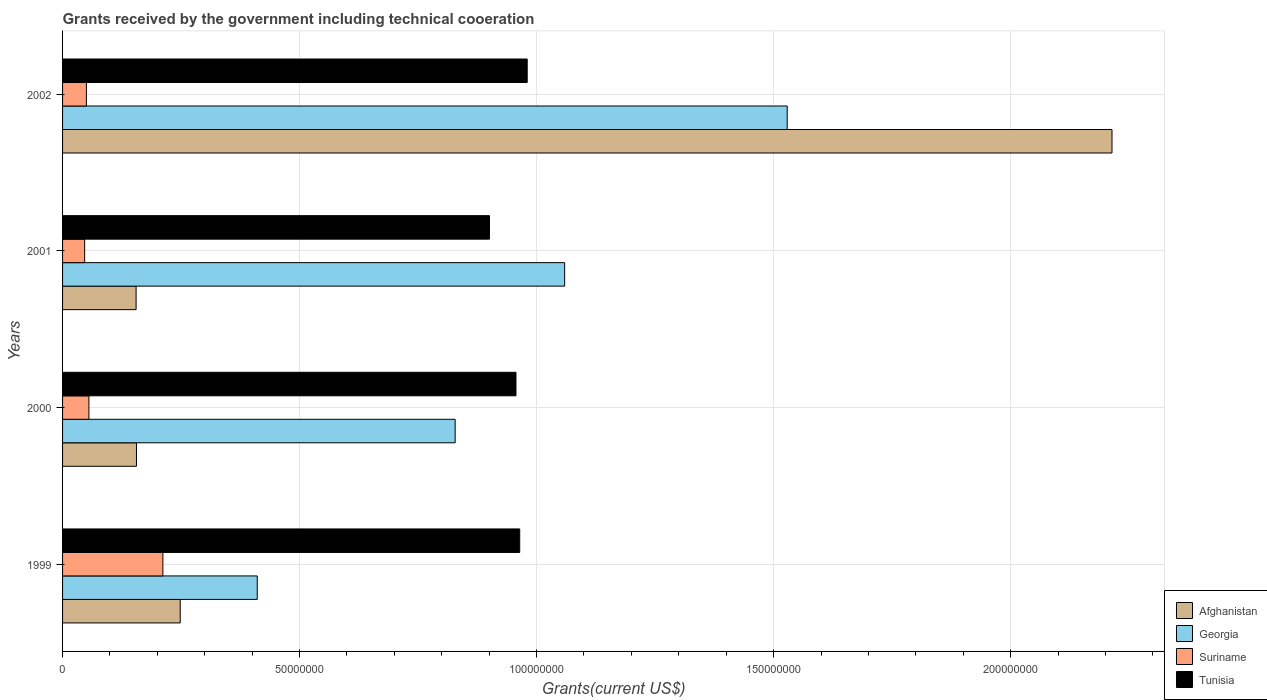Are the number of bars per tick equal to the number of legend labels?
Make the answer very short. Yes. Are the number of bars on each tick of the Y-axis equal?
Your answer should be compact. Yes. How many bars are there on the 3rd tick from the top?
Offer a terse response. 4. What is the label of the 1st group of bars from the top?
Ensure brevity in your answer.  2002. What is the total grants received by the government in Georgia in 2001?
Your response must be concise. 1.06e+08. Across all years, what is the maximum total grants received by the government in Tunisia?
Provide a succinct answer. 9.80e+07. Across all years, what is the minimum total grants received by the government in Afghanistan?
Offer a very short reply. 1.55e+07. What is the total total grants received by the government in Suriname in the graph?
Your answer should be very brief. 3.64e+07. What is the difference between the total grants received by the government in Suriname in 2000 and that in 2002?
Provide a short and direct response. 5.30e+05. What is the difference between the total grants received by the government in Georgia in 2000 and the total grants received by the government in Afghanistan in 2002?
Offer a very short reply. -1.39e+08. What is the average total grants received by the government in Georgia per year?
Your response must be concise. 9.57e+07. In the year 2001, what is the difference between the total grants received by the government in Georgia and total grants received by the government in Tunisia?
Make the answer very short. 1.59e+07. What is the ratio of the total grants received by the government in Suriname in 2000 to that in 2002?
Offer a very short reply. 1.11. Is the difference between the total grants received by the government in Georgia in 1999 and 2000 greater than the difference between the total grants received by the government in Tunisia in 1999 and 2000?
Offer a very short reply. No. What is the difference between the highest and the second highest total grants received by the government in Suriname?
Your answer should be compact. 1.56e+07. What is the difference between the highest and the lowest total grants received by the government in Suriname?
Offer a very short reply. 1.65e+07. Is the sum of the total grants received by the government in Afghanistan in 2000 and 2002 greater than the maximum total grants received by the government in Suriname across all years?
Your answer should be very brief. Yes. Is it the case that in every year, the sum of the total grants received by the government in Tunisia and total grants received by the government in Georgia is greater than the sum of total grants received by the government in Suriname and total grants received by the government in Afghanistan?
Keep it short and to the point. No. What does the 1st bar from the top in 2000 represents?
Make the answer very short. Tunisia. What does the 2nd bar from the bottom in 2001 represents?
Provide a short and direct response. Georgia. How many bars are there?
Your answer should be very brief. 16. What is the difference between two consecutive major ticks on the X-axis?
Keep it short and to the point. 5.00e+07. Are the values on the major ticks of X-axis written in scientific E-notation?
Offer a terse response. No. How many legend labels are there?
Your answer should be compact. 4. What is the title of the graph?
Keep it short and to the point. Grants received by the government including technical cooeration. Does "Sao Tome and Principe" appear as one of the legend labels in the graph?
Your response must be concise. No. What is the label or title of the X-axis?
Provide a succinct answer. Grants(current US$). What is the Grants(current US$) of Afghanistan in 1999?
Provide a short and direct response. 2.48e+07. What is the Grants(current US$) in Georgia in 1999?
Keep it short and to the point. 4.11e+07. What is the Grants(current US$) in Suriname in 1999?
Your answer should be very brief. 2.12e+07. What is the Grants(current US$) of Tunisia in 1999?
Offer a very short reply. 9.64e+07. What is the Grants(current US$) of Afghanistan in 2000?
Your response must be concise. 1.56e+07. What is the Grants(current US$) of Georgia in 2000?
Your answer should be very brief. 8.28e+07. What is the Grants(current US$) of Suriname in 2000?
Make the answer very short. 5.56e+06. What is the Grants(current US$) in Tunisia in 2000?
Offer a terse response. 9.56e+07. What is the Grants(current US$) of Afghanistan in 2001?
Provide a short and direct response. 1.55e+07. What is the Grants(current US$) of Georgia in 2001?
Your response must be concise. 1.06e+08. What is the Grants(current US$) in Suriname in 2001?
Your answer should be very brief. 4.66e+06. What is the Grants(current US$) in Tunisia in 2001?
Your answer should be compact. 9.01e+07. What is the Grants(current US$) in Afghanistan in 2002?
Make the answer very short. 2.21e+08. What is the Grants(current US$) in Georgia in 2002?
Your answer should be compact. 1.53e+08. What is the Grants(current US$) in Suriname in 2002?
Provide a succinct answer. 5.03e+06. What is the Grants(current US$) of Tunisia in 2002?
Offer a terse response. 9.80e+07. Across all years, what is the maximum Grants(current US$) in Afghanistan?
Your answer should be very brief. 2.21e+08. Across all years, what is the maximum Grants(current US$) of Georgia?
Offer a very short reply. 1.53e+08. Across all years, what is the maximum Grants(current US$) in Suriname?
Your answer should be very brief. 2.12e+07. Across all years, what is the maximum Grants(current US$) in Tunisia?
Your answer should be very brief. 9.80e+07. Across all years, what is the minimum Grants(current US$) of Afghanistan?
Offer a very short reply. 1.55e+07. Across all years, what is the minimum Grants(current US$) in Georgia?
Ensure brevity in your answer.  4.11e+07. Across all years, what is the minimum Grants(current US$) of Suriname?
Offer a terse response. 4.66e+06. Across all years, what is the minimum Grants(current US$) in Tunisia?
Provide a short and direct response. 9.01e+07. What is the total Grants(current US$) of Afghanistan in the graph?
Offer a terse response. 2.77e+08. What is the total Grants(current US$) of Georgia in the graph?
Offer a very short reply. 3.83e+08. What is the total Grants(current US$) of Suriname in the graph?
Offer a very short reply. 3.64e+07. What is the total Grants(current US$) in Tunisia in the graph?
Provide a succinct answer. 3.80e+08. What is the difference between the Grants(current US$) of Afghanistan in 1999 and that in 2000?
Your response must be concise. 9.23e+06. What is the difference between the Grants(current US$) of Georgia in 1999 and that in 2000?
Make the answer very short. -4.18e+07. What is the difference between the Grants(current US$) of Suriname in 1999 and that in 2000?
Provide a short and direct response. 1.56e+07. What is the difference between the Grants(current US$) in Tunisia in 1999 and that in 2000?
Your answer should be very brief. 7.90e+05. What is the difference between the Grants(current US$) of Afghanistan in 1999 and that in 2001?
Provide a succinct answer. 9.31e+06. What is the difference between the Grants(current US$) in Georgia in 1999 and that in 2001?
Give a very brief answer. -6.48e+07. What is the difference between the Grants(current US$) in Suriname in 1999 and that in 2001?
Your answer should be very brief. 1.65e+07. What is the difference between the Grants(current US$) of Tunisia in 1999 and that in 2001?
Ensure brevity in your answer.  6.38e+06. What is the difference between the Grants(current US$) in Afghanistan in 1999 and that in 2002?
Ensure brevity in your answer.  -1.97e+08. What is the difference between the Grants(current US$) of Georgia in 1999 and that in 2002?
Your response must be concise. -1.12e+08. What is the difference between the Grants(current US$) in Suriname in 1999 and that in 2002?
Your response must be concise. 1.61e+07. What is the difference between the Grants(current US$) of Tunisia in 1999 and that in 2002?
Your response must be concise. -1.58e+06. What is the difference between the Grants(current US$) in Georgia in 2000 and that in 2001?
Offer a terse response. -2.31e+07. What is the difference between the Grants(current US$) in Tunisia in 2000 and that in 2001?
Offer a very short reply. 5.59e+06. What is the difference between the Grants(current US$) in Afghanistan in 2000 and that in 2002?
Provide a short and direct response. -2.06e+08. What is the difference between the Grants(current US$) in Georgia in 2000 and that in 2002?
Keep it short and to the point. -7.00e+07. What is the difference between the Grants(current US$) in Suriname in 2000 and that in 2002?
Provide a short and direct response. 5.30e+05. What is the difference between the Grants(current US$) in Tunisia in 2000 and that in 2002?
Keep it short and to the point. -2.37e+06. What is the difference between the Grants(current US$) in Afghanistan in 2001 and that in 2002?
Keep it short and to the point. -2.06e+08. What is the difference between the Grants(current US$) in Georgia in 2001 and that in 2002?
Your answer should be compact. -4.70e+07. What is the difference between the Grants(current US$) of Suriname in 2001 and that in 2002?
Ensure brevity in your answer.  -3.70e+05. What is the difference between the Grants(current US$) of Tunisia in 2001 and that in 2002?
Make the answer very short. -7.96e+06. What is the difference between the Grants(current US$) of Afghanistan in 1999 and the Grants(current US$) of Georgia in 2000?
Your response must be concise. -5.80e+07. What is the difference between the Grants(current US$) of Afghanistan in 1999 and the Grants(current US$) of Suriname in 2000?
Your answer should be compact. 1.93e+07. What is the difference between the Grants(current US$) of Afghanistan in 1999 and the Grants(current US$) of Tunisia in 2000?
Your response must be concise. -7.08e+07. What is the difference between the Grants(current US$) of Georgia in 1999 and the Grants(current US$) of Suriname in 2000?
Offer a very short reply. 3.55e+07. What is the difference between the Grants(current US$) in Georgia in 1999 and the Grants(current US$) in Tunisia in 2000?
Keep it short and to the point. -5.46e+07. What is the difference between the Grants(current US$) in Suriname in 1999 and the Grants(current US$) in Tunisia in 2000?
Your answer should be compact. -7.45e+07. What is the difference between the Grants(current US$) in Afghanistan in 1999 and the Grants(current US$) in Georgia in 2001?
Your answer should be compact. -8.11e+07. What is the difference between the Grants(current US$) in Afghanistan in 1999 and the Grants(current US$) in Suriname in 2001?
Offer a terse response. 2.02e+07. What is the difference between the Grants(current US$) of Afghanistan in 1999 and the Grants(current US$) of Tunisia in 2001?
Offer a terse response. -6.52e+07. What is the difference between the Grants(current US$) of Georgia in 1999 and the Grants(current US$) of Suriname in 2001?
Ensure brevity in your answer.  3.64e+07. What is the difference between the Grants(current US$) in Georgia in 1999 and the Grants(current US$) in Tunisia in 2001?
Your answer should be very brief. -4.90e+07. What is the difference between the Grants(current US$) of Suriname in 1999 and the Grants(current US$) of Tunisia in 2001?
Provide a succinct answer. -6.89e+07. What is the difference between the Grants(current US$) of Afghanistan in 1999 and the Grants(current US$) of Georgia in 2002?
Make the answer very short. -1.28e+08. What is the difference between the Grants(current US$) in Afghanistan in 1999 and the Grants(current US$) in Suriname in 2002?
Provide a short and direct response. 1.98e+07. What is the difference between the Grants(current US$) in Afghanistan in 1999 and the Grants(current US$) in Tunisia in 2002?
Offer a very short reply. -7.32e+07. What is the difference between the Grants(current US$) of Georgia in 1999 and the Grants(current US$) of Suriname in 2002?
Provide a succinct answer. 3.60e+07. What is the difference between the Grants(current US$) in Georgia in 1999 and the Grants(current US$) in Tunisia in 2002?
Provide a succinct answer. -5.70e+07. What is the difference between the Grants(current US$) of Suriname in 1999 and the Grants(current US$) of Tunisia in 2002?
Offer a very short reply. -7.69e+07. What is the difference between the Grants(current US$) of Afghanistan in 2000 and the Grants(current US$) of Georgia in 2001?
Ensure brevity in your answer.  -9.03e+07. What is the difference between the Grants(current US$) in Afghanistan in 2000 and the Grants(current US$) in Suriname in 2001?
Your answer should be compact. 1.09e+07. What is the difference between the Grants(current US$) in Afghanistan in 2000 and the Grants(current US$) in Tunisia in 2001?
Offer a very short reply. -7.45e+07. What is the difference between the Grants(current US$) in Georgia in 2000 and the Grants(current US$) in Suriname in 2001?
Your answer should be compact. 7.82e+07. What is the difference between the Grants(current US$) in Georgia in 2000 and the Grants(current US$) in Tunisia in 2001?
Ensure brevity in your answer.  -7.24e+06. What is the difference between the Grants(current US$) in Suriname in 2000 and the Grants(current US$) in Tunisia in 2001?
Provide a succinct answer. -8.45e+07. What is the difference between the Grants(current US$) of Afghanistan in 2000 and the Grants(current US$) of Georgia in 2002?
Your response must be concise. -1.37e+08. What is the difference between the Grants(current US$) of Afghanistan in 2000 and the Grants(current US$) of Suriname in 2002?
Ensure brevity in your answer.  1.06e+07. What is the difference between the Grants(current US$) in Afghanistan in 2000 and the Grants(current US$) in Tunisia in 2002?
Provide a short and direct response. -8.24e+07. What is the difference between the Grants(current US$) of Georgia in 2000 and the Grants(current US$) of Suriname in 2002?
Your response must be concise. 7.78e+07. What is the difference between the Grants(current US$) of Georgia in 2000 and the Grants(current US$) of Tunisia in 2002?
Give a very brief answer. -1.52e+07. What is the difference between the Grants(current US$) of Suriname in 2000 and the Grants(current US$) of Tunisia in 2002?
Your response must be concise. -9.25e+07. What is the difference between the Grants(current US$) of Afghanistan in 2001 and the Grants(current US$) of Georgia in 2002?
Offer a very short reply. -1.37e+08. What is the difference between the Grants(current US$) of Afghanistan in 2001 and the Grants(current US$) of Suriname in 2002?
Provide a succinct answer. 1.05e+07. What is the difference between the Grants(current US$) in Afghanistan in 2001 and the Grants(current US$) in Tunisia in 2002?
Offer a very short reply. -8.25e+07. What is the difference between the Grants(current US$) in Georgia in 2001 and the Grants(current US$) in Suriname in 2002?
Your answer should be very brief. 1.01e+08. What is the difference between the Grants(current US$) of Georgia in 2001 and the Grants(current US$) of Tunisia in 2002?
Offer a very short reply. 7.90e+06. What is the difference between the Grants(current US$) in Suriname in 2001 and the Grants(current US$) in Tunisia in 2002?
Give a very brief answer. -9.34e+07. What is the average Grants(current US$) in Afghanistan per year?
Your response must be concise. 6.93e+07. What is the average Grants(current US$) in Georgia per year?
Make the answer very short. 9.57e+07. What is the average Grants(current US$) of Suriname per year?
Make the answer very short. 9.10e+06. What is the average Grants(current US$) in Tunisia per year?
Provide a short and direct response. 9.50e+07. In the year 1999, what is the difference between the Grants(current US$) of Afghanistan and Grants(current US$) of Georgia?
Ensure brevity in your answer.  -1.62e+07. In the year 1999, what is the difference between the Grants(current US$) of Afghanistan and Grants(current US$) of Suriname?
Offer a terse response. 3.66e+06. In the year 1999, what is the difference between the Grants(current US$) of Afghanistan and Grants(current US$) of Tunisia?
Provide a succinct answer. -7.16e+07. In the year 1999, what is the difference between the Grants(current US$) of Georgia and Grants(current US$) of Suriname?
Your answer should be very brief. 1.99e+07. In the year 1999, what is the difference between the Grants(current US$) of Georgia and Grants(current US$) of Tunisia?
Ensure brevity in your answer.  -5.54e+07. In the year 1999, what is the difference between the Grants(current US$) in Suriname and Grants(current US$) in Tunisia?
Your answer should be compact. -7.53e+07. In the year 2000, what is the difference between the Grants(current US$) in Afghanistan and Grants(current US$) in Georgia?
Your answer should be very brief. -6.72e+07. In the year 2000, what is the difference between the Grants(current US$) in Afghanistan and Grants(current US$) in Suriname?
Your answer should be very brief. 1.00e+07. In the year 2000, what is the difference between the Grants(current US$) in Afghanistan and Grants(current US$) in Tunisia?
Give a very brief answer. -8.01e+07. In the year 2000, what is the difference between the Grants(current US$) of Georgia and Grants(current US$) of Suriname?
Offer a terse response. 7.73e+07. In the year 2000, what is the difference between the Grants(current US$) in Georgia and Grants(current US$) in Tunisia?
Your answer should be compact. -1.28e+07. In the year 2000, what is the difference between the Grants(current US$) of Suriname and Grants(current US$) of Tunisia?
Make the answer very short. -9.01e+07. In the year 2001, what is the difference between the Grants(current US$) in Afghanistan and Grants(current US$) in Georgia?
Provide a succinct answer. -9.04e+07. In the year 2001, what is the difference between the Grants(current US$) in Afghanistan and Grants(current US$) in Suriname?
Ensure brevity in your answer.  1.08e+07. In the year 2001, what is the difference between the Grants(current US$) in Afghanistan and Grants(current US$) in Tunisia?
Offer a terse response. -7.46e+07. In the year 2001, what is the difference between the Grants(current US$) of Georgia and Grants(current US$) of Suriname?
Provide a succinct answer. 1.01e+08. In the year 2001, what is the difference between the Grants(current US$) in Georgia and Grants(current US$) in Tunisia?
Make the answer very short. 1.59e+07. In the year 2001, what is the difference between the Grants(current US$) in Suriname and Grants(current US$) in Tunisia?
Keep it short and to the point. -8.54e+07. In the year 2002, what is the difference between the Grants(current US$) in Afghanistan and Grants(current US$) in Georgia?
Provide a short and direct response. 6.85e+07. In the year 2002, what is the difference between the Grants(current US$) of Afghanistan and Grants(current US$) of Suriname?
Give a very brief answer. 2.16e+08. In the year 2002, what is the difference between the Grants(current US$) in Afghanistan and Grants(current US$) in Tunisia?
Your answer should be very brief. 1.23e+08. In the year 2002, what is the difference between the Grants(current US$) of Georgia and Grants(current US$) of Suriname?
Ensure brevity in your answer.  1.48e+08. In the year 2002, what is the difference between the Grants(current US$) in Georgia and Grants(current US$) in Tunisia?
Your answer should be very brief. 5.48e+07. In the year 2002, what is the difference between the Grants(current US$) of Suriname and Grants(current US$) of Tunisia?
Give a very brief answer. -9.30e+07. What is the ratio of the Grants(current US$) in Afghanistan in 1999 to that in 2000?
Provide a succinct answer. 1.59. What is the ratio of the Grants(current US$) of Georgia in 1999 to that in 2000?
Your answer should be very brief. 0.5. What is the ratio of the Grants(current US$) in Suriname in 1999 to that in 2000?
Your answer should be very brief. 3.81. What is the ratio of the Grants(current US$) in Tunisia in 1999 to that in 2000?
Your response must be concise. 1.01. What is the ratio of the Grants(current US$) in Afghanistan in 1999 to that in 2001?
Provide a succinct answer. 1.6. What is the ratio of the Grants(current US$) of Georgia in 1999 to that in 2001?
Your answer should be very brief. 0.39. What is the ratio of the Grants(current US$) in Suriname in 1999 to that in 2001?
Give a very brief answer. 4.54. What is the ratio of the Grants(current US$) in Tunisia in 1999 to that in 2001?
Provide a short and direct response. 1.07. What is the ratio of the Grants(current US$) in Afghanistan in 1999 to that in 2002?
Your answer should be compact. 0.11. What is the ratio of the Grants(current US$) of Georgia in 1999 to that in 2002?
Give a very brief answer. 0.27. What is the ratio of the Grants(current US$) in Suriname in 1999 to that in 2002?
Your response must be concise. 4.21. What is the ratio of the Grants(current US$) in Tunisia in 1999 to that in 2002?
Keep it short and to the point. 0.98. What is the ratio of the Grants(current US$) of Afghanistan in 2000 to that in 2001?
Provide a short and direct response. 1.01. What is the ratio of the Grants(current US$) in Georgia in 2000 to that in 2001?
Offer a very short reply. 0.78. What is the ratio of the Grants(current US$) of Suriname in 2000 to that in 2001?
Provide a short and direct response. 1.19. What is the ratio of the Grants(current US$) of Tunisia in 2000 to that in 2001?
Make the answer very short. 1.06. What is the ratio of the Grants(current US$) of Afghanistan in 2000 to that in 2002?
Ensure brevity in your answer.  0.07. What is the ratio of the Grants(current US$) of Georgia in 2000 to that in 2002?
Your answer should be very brief. 0.54. What is the ratio of the Grants(current US$) in Suriname in 2000 to that in 2002?
Your answer should be compact. 1.11. What is the ratio of the Grants(current US$) in Tunisia in 2000 to that in 2002?
Ensure brevity in your answer.  0.98. What is the ratio of the Grants(current US$) in Afghanistan in 2001 to that in 2002?
Make the answer very short. 0.07. What is the ratio of the Grants(current US$) in Georgia in 2001 to that in 2002?
Provide a short and direct response. 0.69. What is the ratio of the Grants(current US$) of Suriname in 2001 to that in 2002?
Give a very brief answer. 0.93. What is the ratio of the Grants(current US$) in Tunisia in 2001 to that in 2002?
Provide a succinct answer. 0.92. What is the difference between the highest and the second highest Grants(current US$) of Afghanistan?
Keep it short and to the point. 1.97e+08. What is the difference between the highest and the second highest Grants(current US$) of Georgia?
Provide a short and direct response. 4.70e+07. What is the difference between the highest and the second highest Grants(current US$) in Suriname?
Ensure brevity in your answer.  1.56e+07. What is the difference between the highest and the second highest Grants(current US$) of Tunisia?
Your response must be concise. 1.58e+06. What is the difference between the highest and the lowest Grants(current US$) in Afghanistan?
Your response must be concise. 2.06e+08. What is the difference between the highest and the lowest Grants(current US$) of Georgia?
Keep it short and to the point. 1.12e+08. What is the difference between the highest and the lowest Grants(current US$) in Suriname?
Your answer should be very brief. 1.65e+07. What is the difference between the highest and the lowest Grants(current US$) in Tunisia?
Your answer should be very brief. 7.96e+06. 